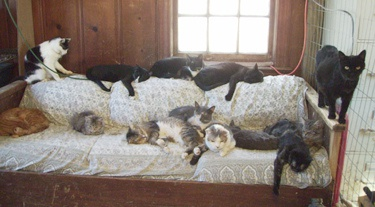Describe the objects in this image and their specific colors. I can see couch in black, darkgray, lightgray, maroon, and gray tones, cat in black, gray, and darkgray tones, cat in black, gray, darkgray, and lightgray tones, cat in black, lightgray, darkgray, and gray tones, and cat in black, gray, and darkgray tones in this image. 